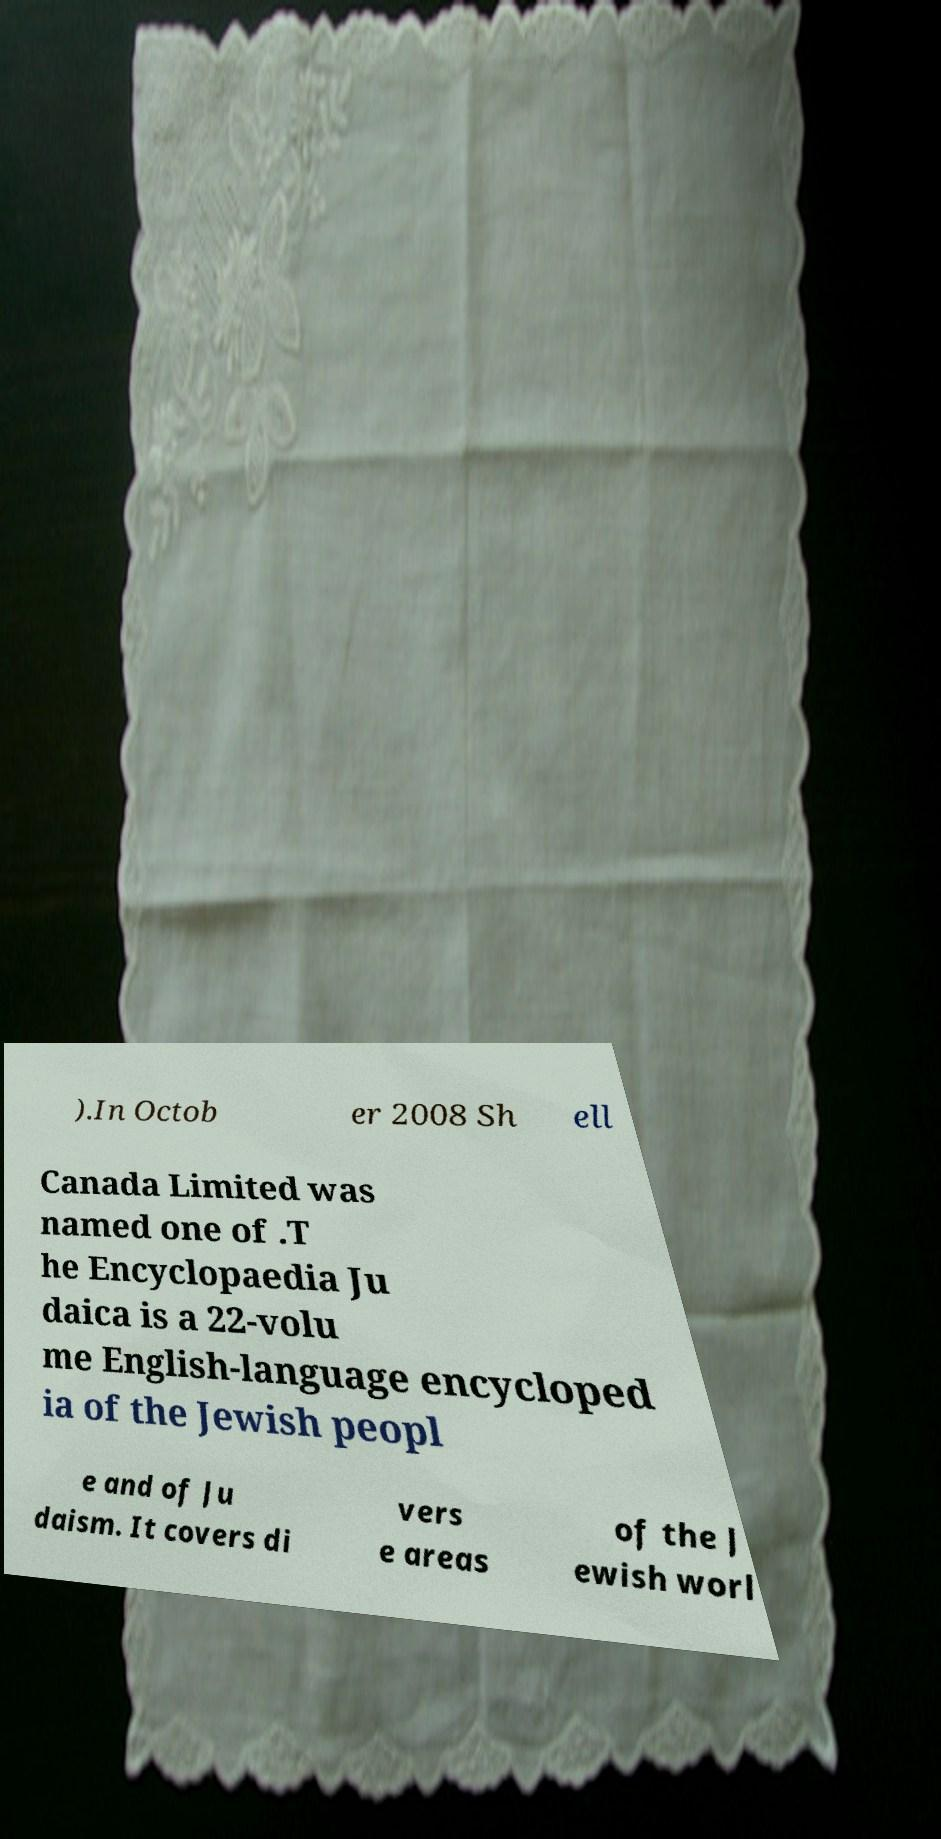What messages or text are displayed in this image? I need them in a readable, typed format. ).In Octob er 2008 Sh ell Canada Limited was named one of .T he Encyclopaedia Ju daica is a 22-volu me English-language encycloped ia of the Jewish peopl e and of Ju daism. It covers di vers e areas of the J ewish worl 